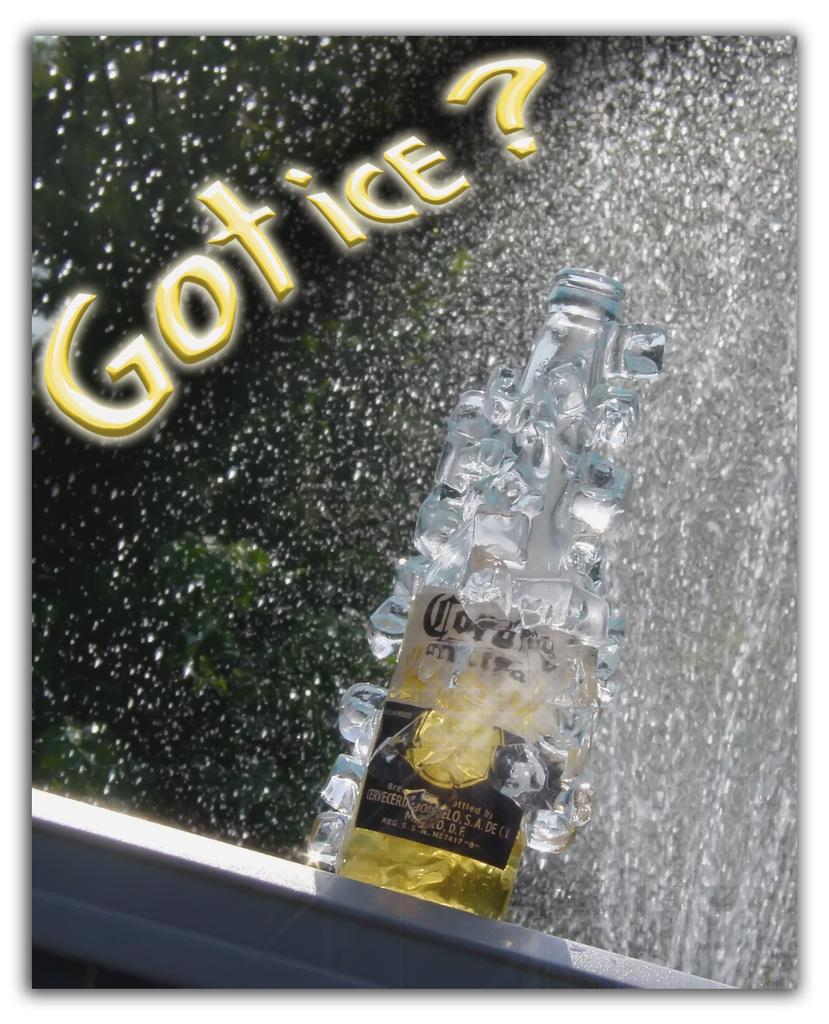What object is placed on the table in the image? There is a bottle on a table in the image. What is present in the image that indicates a cold substance? There are ice cubes in the image. What is happening to the bottle in the image? Water is poured on the bottle in the image. Can you describe any text in the image? There is edited text in the image. What type of animals can be seen at the zoo in the image? There is no zoo or animals present in the image. How many stalks of celery are visible in the image? There is no celery present in the image. 